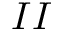Convert formula to latex. <formula><loc_0><loc_0><loc_500><loc_500>I I</formula> 